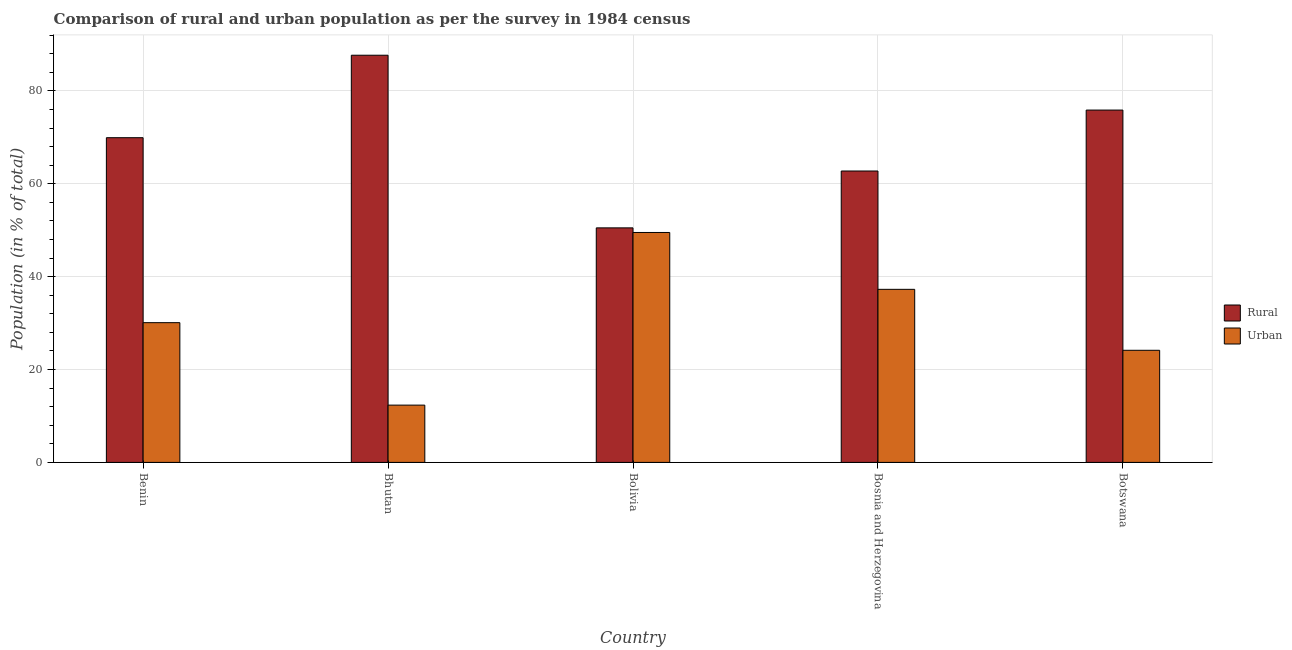How many different coloured bars are there?
Ensure brevity in your answer.  2. How many groups of bars are there?
Make the answer very short. 5. How many bars are there on the 1st tick from the left?
Provide a short and direct response. 2. What is the rural population in Benin?
Your answer should be very brief. 69.91. Across all countries, what is the maximum urban population?
Provide a succinct answer. 49.5. Across all countries, what is the minimum rural population?
Provide a short and direct response. 50.5. In which country was the urban population maximum?
Make the answer very short. Bolivia. In which country was the rural population minimum?
Your answer should be very brief. Bolivia. What is the total urban population in the graph?
Your response must be concise. 153.32. What is the difference between the urban population in Benin and that in Bosnia and Herzegovina?
Your answer should be compact. -7.18. What is the difference between the rural population in Benin and the urban population in Bhutan?
Keep it short and to the point. 57.58. What is the average urban population per country?
Keep it short and to the point. 30.66. What is the difference between the urban population and rural population in Benin?
Provide a succinct answer. -39.83. In how many countries, is the urban population greater than 36 %?
Provide a succinct answer. 2. What is the ratio of the urban population in Benin to that in Bhutan?
Give a very brief answer. 2.44. Is the difference between the urban population in Bhutan and Bosnia and Herzegovina greater than the difference between the rural population in Bhutan and Bosnia and Herzegovina?
Your response must be concise. No. What is the difference between the highest and the second highest urban population?
Your answer should be compact. 12.24. What is the difference between the highest and the lowest rural population?
Ensure brevity in your answer.  37.17. In how many countries, is the rural population greater than the average rural population taken over all countries?
Make the answer very short. 3. What does the 1st bar from the left in Bhutan represents?
Make the answer very short. Rural. What does the 1st bar from the right in Bosnia and Herzegovina represents?
Provide a short and direct response. Urban. How many countries are there in the graph?
Keep it short and to the point. 5. What is the difference between two consecutive major ticks on the Y-axis?
Give a very brief answer. 20. Are the values on the major ticks of Y-axis written in scientific E-notation?
Your answer should be compact. No. Does the graph contain any zero values?
Your answer should be very brief. No. Does the graph contain grids?
Ensure brevity in your answer.  Yes. How are the legend labels stacked?
Your response must be concise. Vertical. What is the title of the graph?
Make the answer very short. Comparison of rural and urban population as per the survey in 1984 census. What is the label or title of the Y-axis?
Provide a succinct answer. Population (in % of total). What is the Population (in % of total) of Rural in Benin?
Provide a short and direct response. 69.91. What is the Population (in % of total) in Urban in Benin?
Provide a succinct answer. 30.09. What is the Population (in % of total) in Rural in Bhutan?
Ensure brevity in your answer.  87.67. What is the Population (in % of total) of Urban in Bhutan?
Provide a succinct answer. 12.33. What is the Population (in % of total) in Rural in Bolivia?
Provide a short and direct response. 50.5. What is the Population (in % of total) of Urban in Bolivia?
Ensure brevity in your answer.  49.5. What is the Population (in % of total) of Rural in Bosnia and Herzegovina?
Provide a short and direct response. 62.74. What is the Population (in % of total) in Urban in Bosnia and Herzegovina?
Ensure brevity in your answer.  37.26. What is the Population (in % of total) in Rural in Botswana?
Ensure brevity in your answer.  75.86. What is the Population (in % of total) of Urban in Botswana?
Ensure brevity in your answer.  24.14. Across all countries, what is the maximum Population (in % of total) of Rural?
Provide a short and direct response. 87.67. Across all countries, what is the maximum Population (in % of total) in Urban?
Provide a short and direct response. 49.5. Across all countries, what is the minimum Population (in % of total) of Rural?
Your response must be concise. 50.5. Across all countries, what is the minimum Population (in % of total) in Urban?
Make the answer very short. 12.33. What is the total Population (in % of total) in Rural in the graph?
Your response must be concise. 346.68. What is the total Population (in % of total) of Urban in the graph?
Your answer should be very brief. 153.32. What is the difference between the Population (in % of total) in Rural in Benin and that in Bhutan?
Your answer should be very brief. -17.75. What is the difference between the Population (in % of total) in Urban in Benin and that in Bhutan?
Ensure brevity in your answer.  17.75. What is the difference between the Population (in % of total) of Rural in Benin and that in Bolivia?
Give a very brief answer. 19.42. What is the difference between the Population (in % of total) of Urban in Benin and that in Bolivia?
Offer a very short reply. -19.42. What is the difference between the Population (in % of total) in Rural in Benin and that in Bosnia and Herzegovina?
Make the answer very short. 7.17. What is the difference between the Population (in % of total) in Urban in Benin and that in Bosnia and Herzegovina?
Give a very brief answer. -7.17. What is the difference between the Population (in % of total) in Rural in Benin and that in Botswana?
Provide a succinct answer. -5.95. What is the difference between the Population (in % of total) in Urban in Benin and that in Botswana?
Offer a very short reply. 5.95. What is the difference between the Population (in % of total) of Rural in Bhutan and that in Bolivia?
Offer a terse response. 37.17. What is the difference between the Population (in % of total) in Urban in Bhutan and that in Bolivia?
Make the answer very short. -37.17. What is the difference between the Population (in % of total) of Rural in Bhutan and that in Bosnia and Herzegovina?
Provide a succinct answer. 24.93. What is the difference between the Population (in % of total) in Urban in Bhutan and that in Bosnia and Herzegovina?
Ensure brevity in your answer.  -24.93. What is the difference between the Population (in % of total) of Rural in Bhutan and that in Botswana?
Your response must be concise. 11.81. What is the difference between the Population (in % of total) of Urban in Bhutan and that in Botswana?
Provide a short and direct response. -11.81. What is the difference between the Population (in % of total) in Rural in Bolivia and that in Bosnia and Herzegovina?
Offer a very short reply. -12.24. What is the difference between the Population (in % of total) in Urban in Bolivia and that in Bosnia and Herzegovina?
Keep it short and to the point. 12.24. What is the difference between the Population (in % of total) of Rural in Bolivia and that in Botswana?
Your answer should be compact. -25.36. What is the difference between the Population (in % of total) in Urban in Bolivia and that in Botswana?
Provide a short and direct response. 25.36. What is the difference between the Population (in % of total) in Rural in Bosnia and Herzegovina and that in Botswana?
Provide a short and direct response. -13.12. What is the difference between the Population (in % of total) in Urban in Bosnia and Herzegovina and that in Botswana?
Offer a terse response. 13.12. What is the difference between the Population (in % of total) in Rural in Benin and the Population (in % of total) in Urban in Bhutan?
Keep it short and to the point. 57.58. What is the difference between the Population (in % of total) of Rural in Benin and the Population (in % of total) of Urban in Bolivia?
Offer a terse response. 20.41. What is the difference between the Population (in % of total) of Rural in Benin and the Population (in % of total) of Urban in Bosnia and Herzegovina?
Give a very brief answer. 32.65. What is the difference between the Population (in % of total) in Rural in Benin and the Population (in % of total) in Urban in Botswana?
Your answer should be compact. 45.77. What is the difference between the Population (in % of total) in Rural in Bhutan and the Population (in % of total) in Urban in Bolivia?
Your answer should be very brief. 38.16. What is the difference between the Population (in % of total) of Rural in Bhutan and the Population (in % of total) of Urban in Bosnia and Herzegovina?
Your answer should be compact. 50.41. What is the difference between the Population (in % of total) in Rural in Bhutan and the Population (in % of total) in Urban in Botswana?
Offer a very short reply. 63.53. What is the difference between the Population (in % of total) in Rural in Bolivia and the Population (in % of total) in Urban in Bosnia and Herzegovina?
Offer a terse response. 13.23. What is the difference between the Population (in % of total) of Rural in Bolivia and the Population (in % of total) of Urban in Botswana?
Offer a very short reply. 26.36. What is the difference between the Population (in % of total) of Rural in Bosnia and Herzegovina and the Population (in % of total) of Urban in Botswana?
Ensure brevity in your answer.  38.6. What is the average Population (in % of total) of Rural per country?
Offer a terse response. 69.34. What is the average Population (in % of total) in Urban per country?
Your answer should be compact. 30.66. What is the difference between the Population (in % of total) of Rural and Population (in % of total) of Urban in Benin?
Give a very brief answer. 39.83. What is the difference between the Population (in % of total) of Rural and Population (in % of total) of Urban in Bhutan?
Your answer should be very brief. 75.34. What is the difference between the Population (in % of total) of Rural and Population (in % of total) of Urban in Bosnia and Herzegovina?
Ensure brevity in your answer.  25.48. What is the difference between the Population (in % of total) of Rural and Population (in % of total) of Urban in Botswana?
Make the answer very short. 51.72. What is the ratio of the Population (in % of total) of Rural in Benin to that in Bhutan?
Offer a terse response. 0.8. What is the ratio of the Population (in % of total) of Urban in Benin to that in Bhutan?
Provide a short and direct response. 2.44. What is the ratio of the Population (in % of total) of Rural in Benin to that in Bolivia?
Your answer should be very brief. 1.38. What is the ratio of the Population (in % of total) in Urban in Benin to that in Bolivia?
Provide a short and direct response. 0.61. What is the ratio of the Population (in % of total) of Rural in Benin to that in Bosnia and Herzegovina?
Give a very brief answer. 1.11. What is the ratio of the Population (in % of total) in Urban in Benin to that in Bosnia and Herzegovina?
Provide a succinct answer. 0.81. What is the ratio of the Population (in % of total) in Rural in Benin to that in Botswana?
Keep it short and to the point. 0.92. What is the ratio of the Population (in % of total) in Urban in Benin to that in Botswana?
Your answer should be compact. 1.25. What is the ratio of the Population (in % of total) in Rural in Bhutan to that in Bolivia?
Ensure brevity in your answer.  1.74. What is the ratio of the Population (in % of total) in Urban in Bhutan to that in Bolivia?
Your response must be concise. 0.25. What is the ratio of the Population (in % of total) of Rural in Bhutan to that in Bosnia and Herzegovina?
Your response must be concise. 1.4. What is the ratio of the Population (in % of total) of Urban in Bhutan to that in Bosnia and Herzegovina?
Make the answer very short. 0.33. What is the ratio of the Population (in % of total) in Rural in Bhutan to that in Botswana?
Your answer should be compact. 1.16. What is the ratio of the Population (in % of total) in Urban in Bhutan to that in Botswana?
Make the answer very short. 0.51. What is the ratio of the Population (in % of total) in Rural in Bolivia to that in Bosnia and Herzegovina?
Your answer should be very brief. 0.8. What is the ratio of the Population (in % of total) of Urban in Bolivia to that in Bosnia and Herzegovina?
Keep it short and to the point. 1.33. What is the ratio of the Population (in % of total) of Rural in Bolivia to that in Botswana?
Your response must be concise. 0.67. What is the ratio of the Population (in % of total) in Urban in Bolivia to that in Botswana?
Give a very brief answer. 2.05. What is the ratio of the Population (in % of total) of Rural in Bosnia and Herzegovina to that in Botswana?
Your response must be concise. 0.83. What is the ratio of the Population (in % of total) in Urban in Bosnia and Herzegovina to that in Botswana?
Make the answer very short. 1.54. What is the difference between the highest and the second highest Population (in % of total) in Rural?
Your answer should be very brief. 11.81. What is the difference between the highest and the second highest Population (in % of total) of Urban?
Ensure brevity in your answer.  12.24. What is the difference between the highest and the lowest Population (in % of total) in Rural?
Your answer should be very brief. 37.17. What is the difference between the highest and the lowest Population (in % of total) in Urban?
Provide a short and direct response. 37.17. 